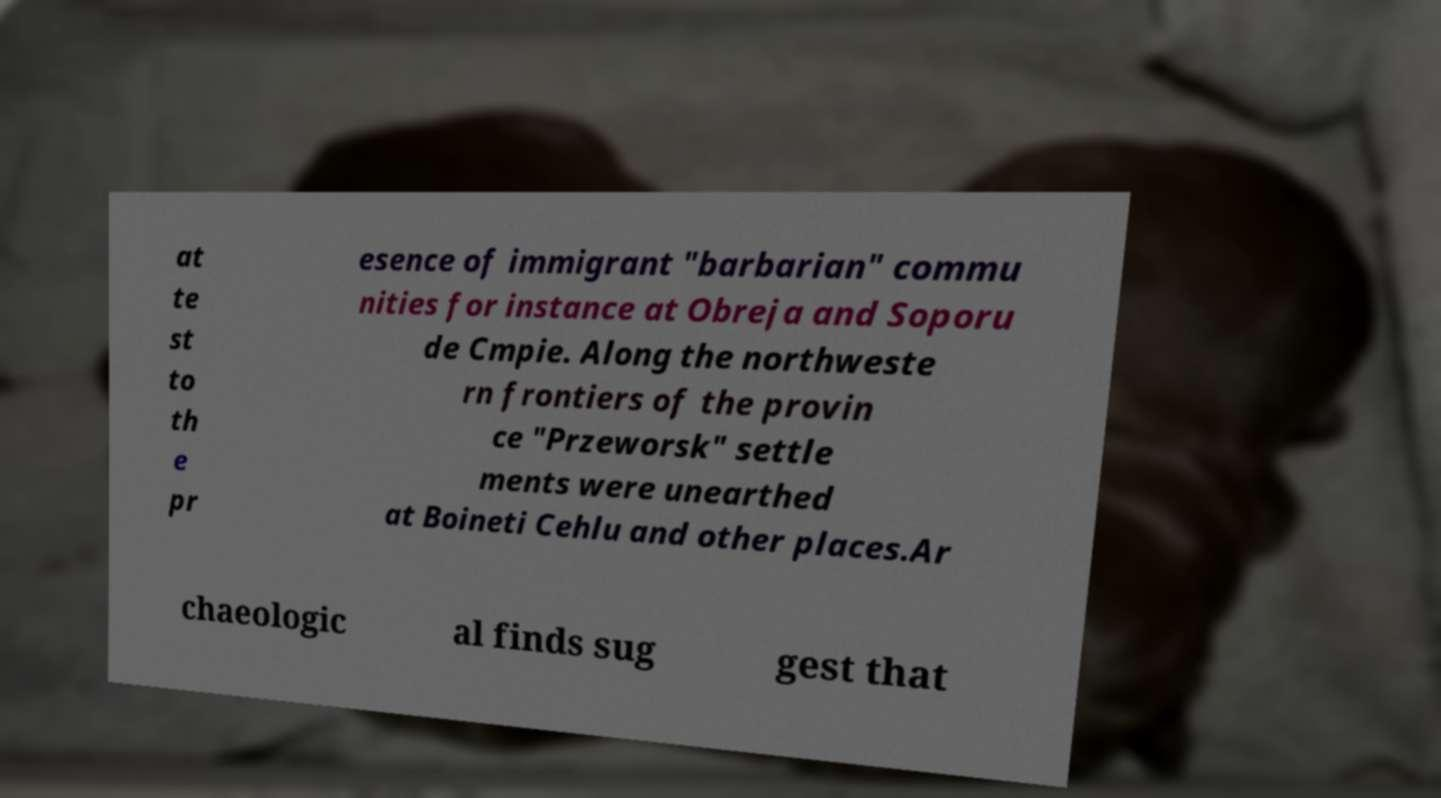I need the written content from this picture converted into text. Can you do that? at te st to th e pr esence of immigrant "barbarian" commu nities for instance at Obreja and Soporu de Cmpie. Along the northweste rn frontiers of the provin ce "Przeworsk" settle ments were unearthed at Boineti Cehlu and other places.Ar chaeologic al finds sug gest that 